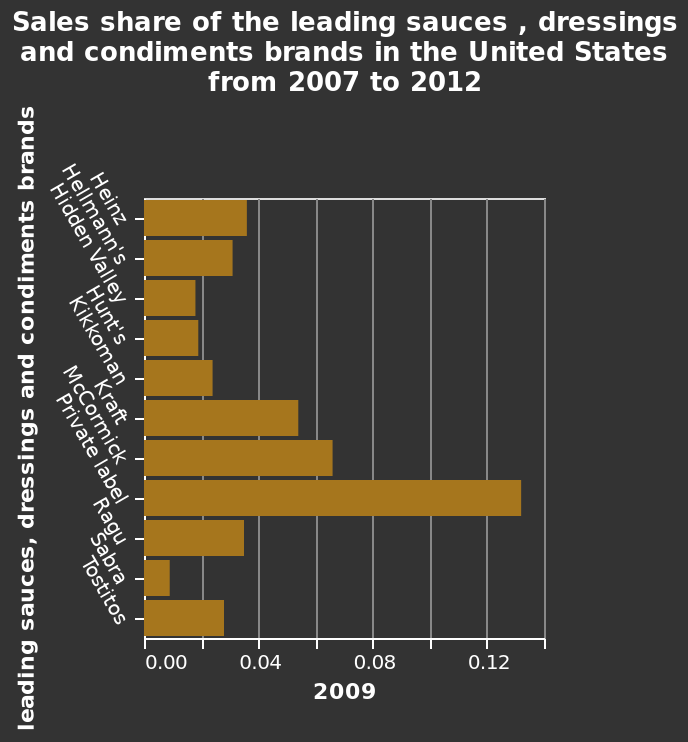<image>
Offer a thorough analysis of the image. Privately labelled sauces , dressings and condiments brands in the United States in 2009 have the most sales shares whereas Sabra has the least. What type of products had the highest sales shares in the United States in 2009? Sauces, dressings, and condiments. What is the subject matter of the bar chart? The bar chart presents the sales share of the leading sauces, dressings, and condiments brands in the United States during the specified time period. Which category of products had the highest sales shares in the United States in 2009? Privately labelled sauces, dressings, and condiments brands. 